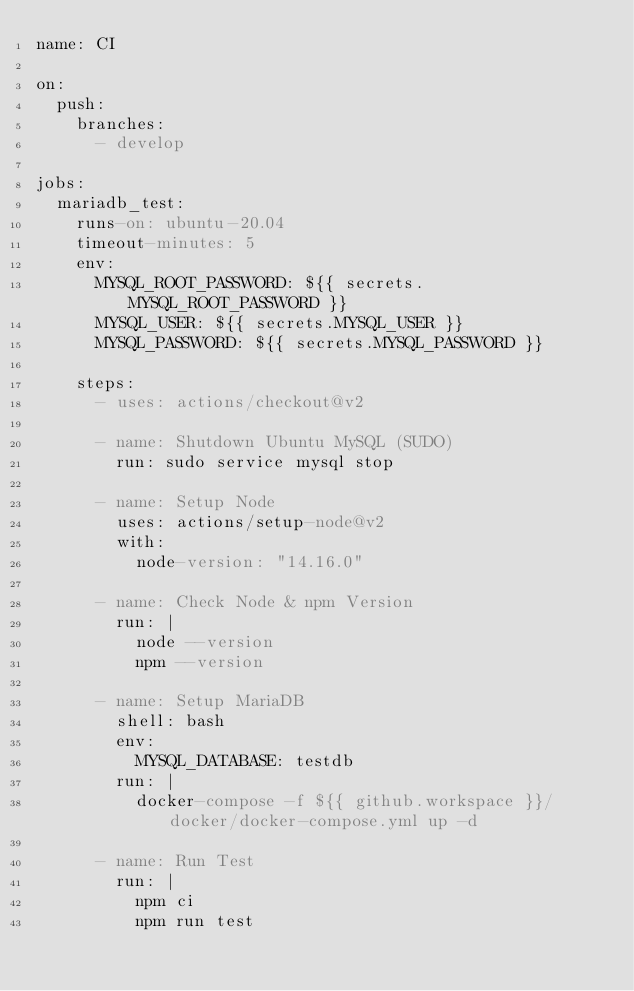<code> <loc_0><loc_0><loc_500><loc_500><_YAML_>name: CI

on:
  push:
    branches:
      - develop

jobs:
  mariadb_test:
    runs-on: ubuntu-20.04
    timeout-minutes: 5
    env:
      MYSQL_ROOT_PASSWORD: ${{ secrets.MYSQL_ROOT_PASSWORD }}
      MYSQL_USER: ${{ secrets.MYSQL_USER }}
      MYSQL_PASSWORD: ${{ secrets.MYSQL_PASSWORD }}

    steps:
      - uses: actions/checkout@v2

      - name: Shutdown Ubuntu MySQL (SUDO)
        run: sudo service mysql stop

      - name: Setup Node
        uses: actions/setup-node@v2
        with:
          node-version: "14.16.0"

      - name: Check Node & npm Version
        run: |
          node --version
          npm --version

      - name: Setup MariaDB
        shell: bash
        env:
          MYSQL_DATABASE: testdb
        run: |
          docker-compose -f ${{ github.workspace }}/docker/docker-compose.yml up -d

      - name: Run Test
        run: |
          npm ci
          npm run test
</code> 